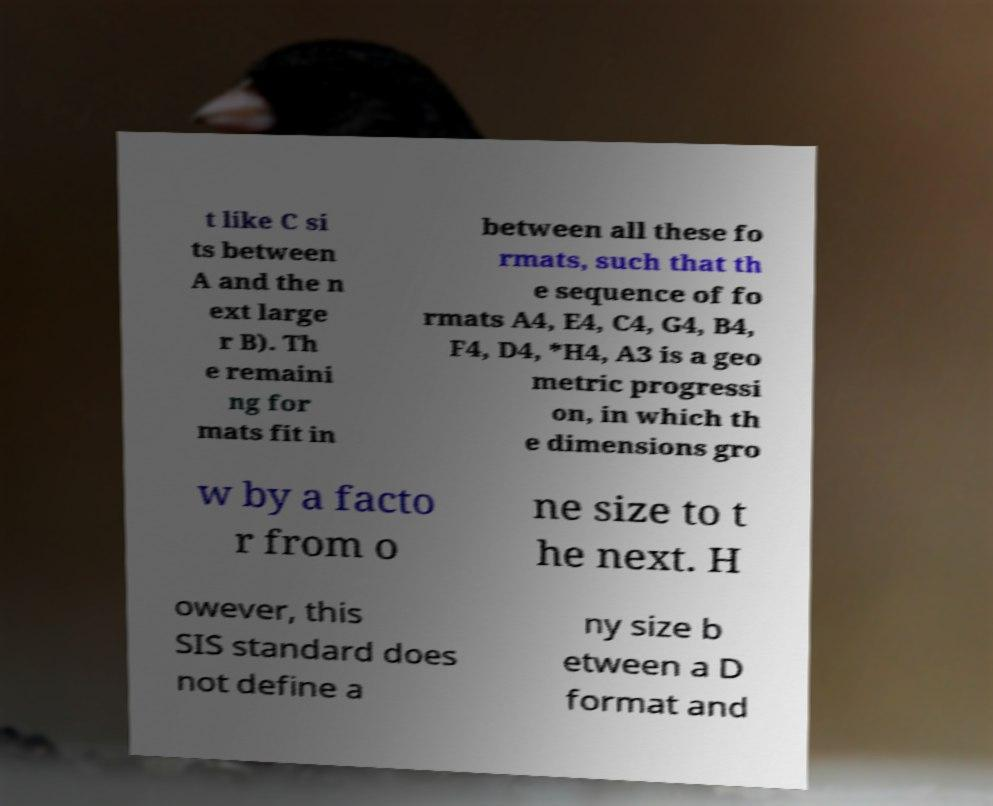There's text embedded in this image that I need extracted. Can you transcribe it verbatim? t like C si ts between A and the n ext large r B). Th e remaini ng for mats fit in between all these fo rmats, such that th e sequence of fo rmats A4, E4, C4, G4, B4, F4, D4, *H4, A3 is a geo metric progressi on, in which th e dimensions gro w by a facto r from o ne size to t he next. H owever, this SIS standard does not define a ny size b etween a D format and 